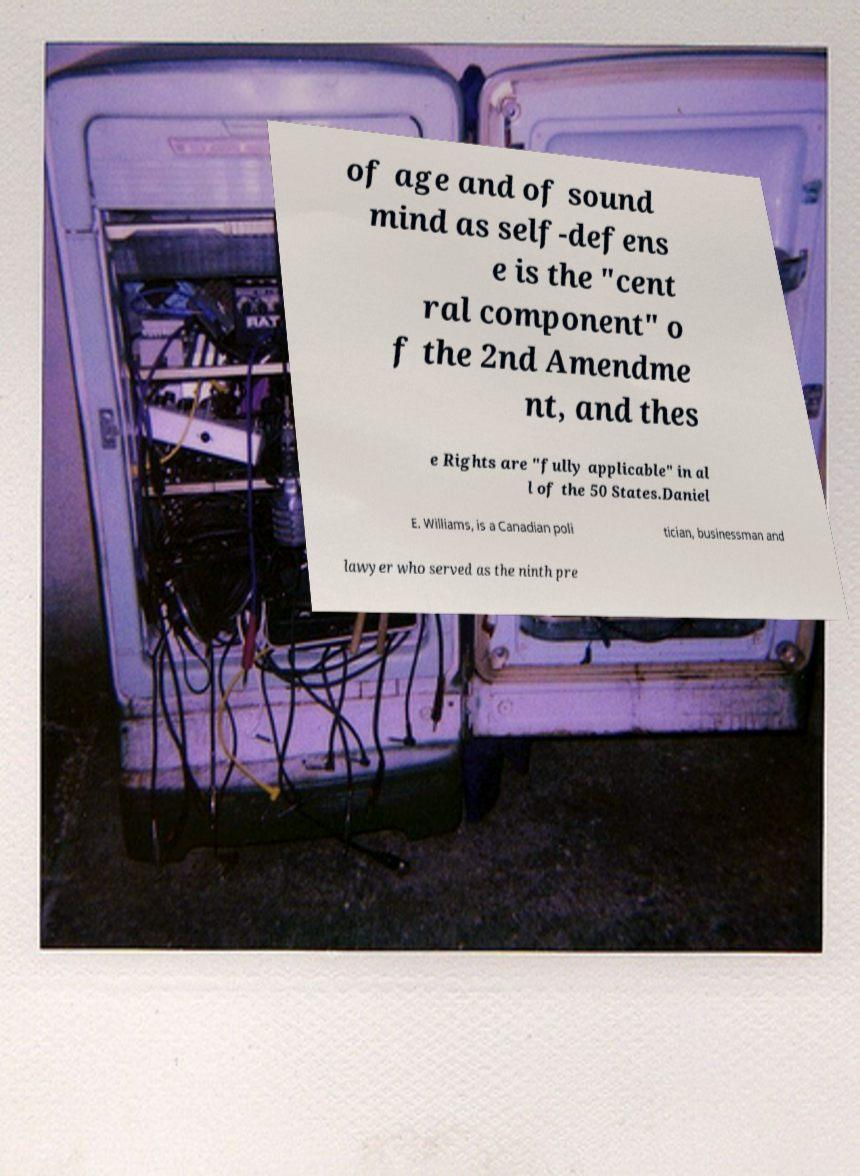I need the written content from this picture converted into text. Can you do that? of age and of sound mind as self-defens e is the "cent ral component" o f the 2nd Amendme nt, and thes e Rights are "fully applicable" in al l of the 50 States.Daniel E. Williams, is a Canadian poli tician, businessman and lawyer who served as the ninth pre 